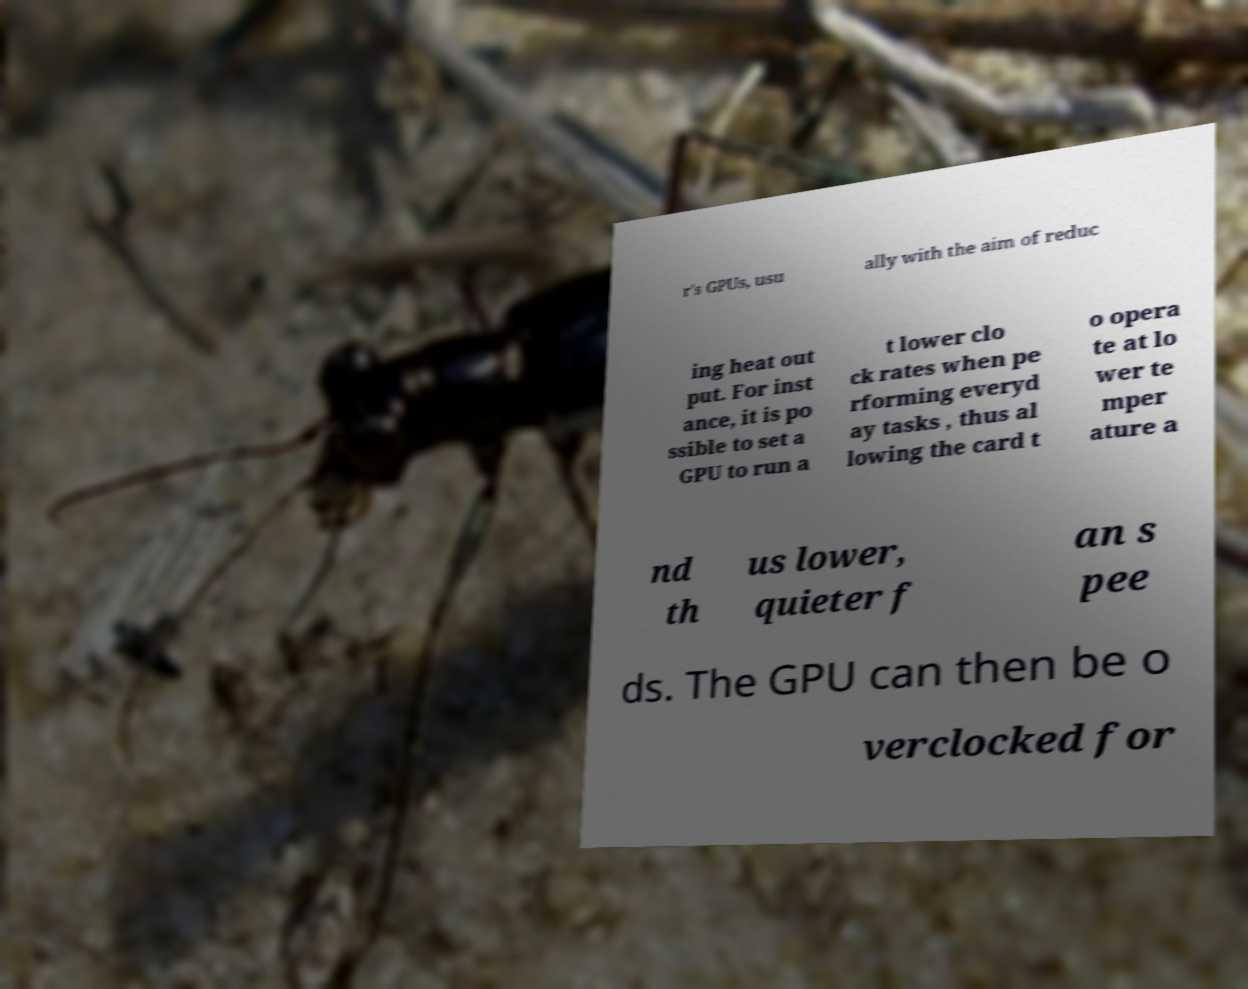Can you read and provide the text displayed in the image?This photo seems to have some interesting text. Can you extract and type it out for me? r's GPUs, usu ally with the aim of reduc ing heat out put. For inst ance, it is po ssible to set a GPU to run a t lower clo ck rates when pe rforming everyd ay tasks , thus al lowing the card t o opera te at lo wer te mper ature a nd th us lower, quieter f an s pee ds. The GPU can then be o verclocked for 